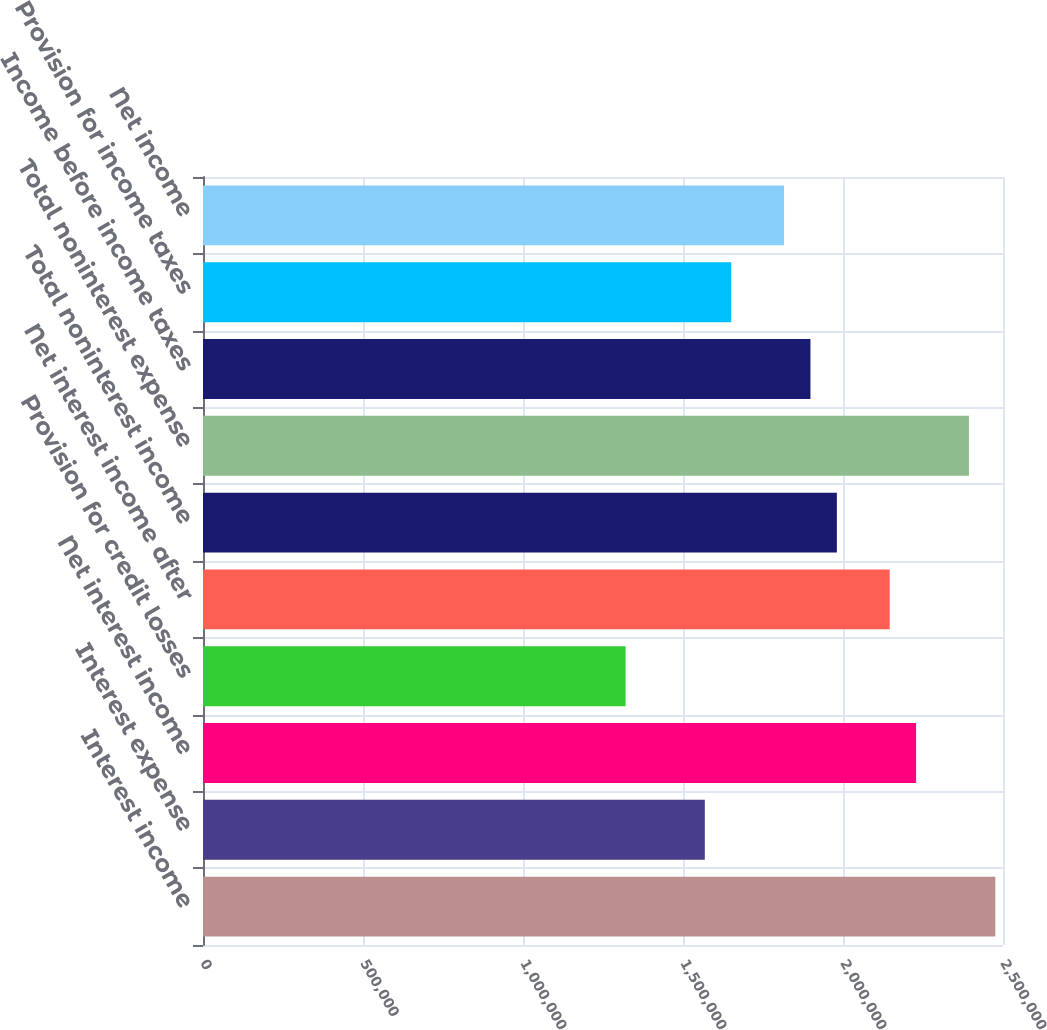<chart> <loc_0><loc_0><loc_500><loc_500><bar_chart><fcel>Interest income<fcel>Interest expense<fcel>Net interest income<fcel>Provision for credit losses<fcel>Net interest income after<fcel>Total noninterest income<fcel>Total noninterest expense<fcel>Income before income taxes<fcel>Provision for income taxes<fcel>Net income<nl><fcel>2.47601e+06<fcel>1.56814e+06<fcel>2.22841e+06<fcel>1.32054e+06<fcel>2.14588e+06<fcel>1.98081e+06<fcel>2.39348e+06<fcel>1.89828e+06<fcel>1.65068e+06<fcel>1.81574e+06<nl></chart> 